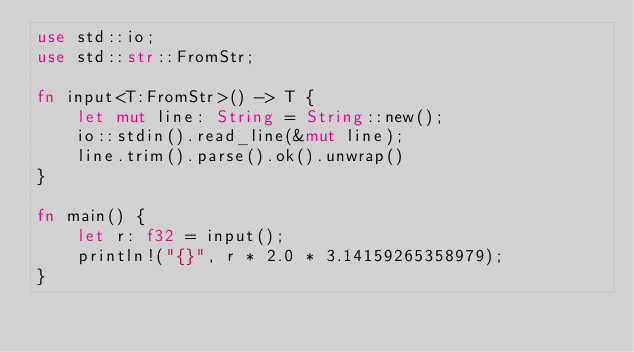<code> <loc_0><loc_0><loc_500><loc_500><_Rust_>use std::io;
use std::str::FromStr;

fn input<T:FromStr>() -> T {
    let mut line: String = String::new();
    io::stdin().read_line(&mut line);
    line.trim().parse().ok().unwrap()
}

fn main() {
    let r: f32 = input();
    println!("{}", r * 2.0 * 3.14159265358979);
}
</code> 